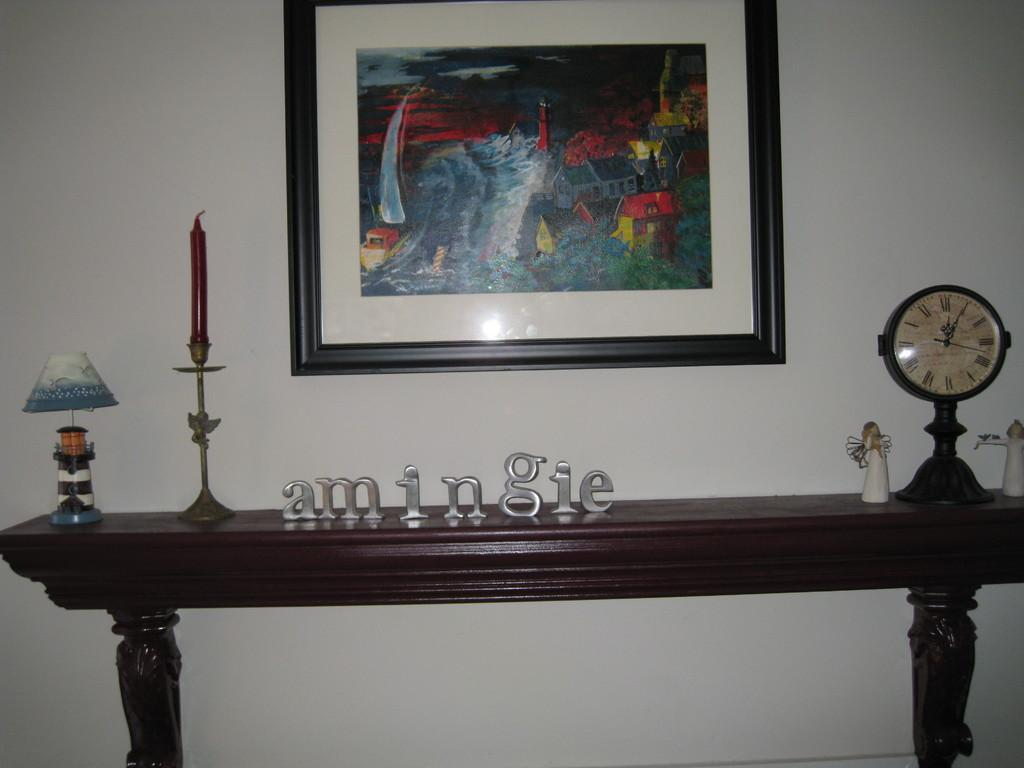<image>
Render a clear and concise summary of the photo. A table has the word amingie spelled out on top of it. 